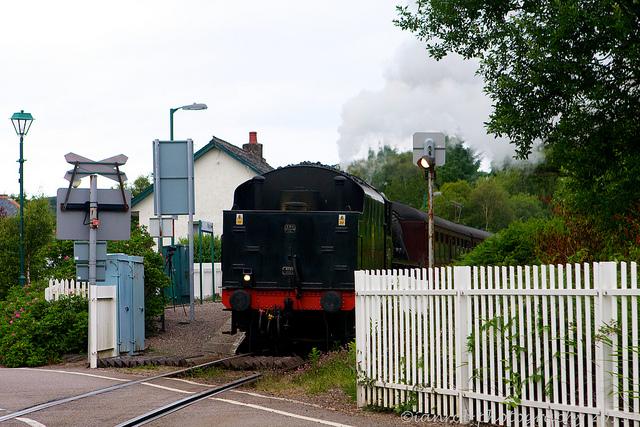What is crossing the road?
Concise answer only. Train. How many street lamps are there?
Keep it brief. 2. Is the train passing a garden?
Answer briefly. Yes. 